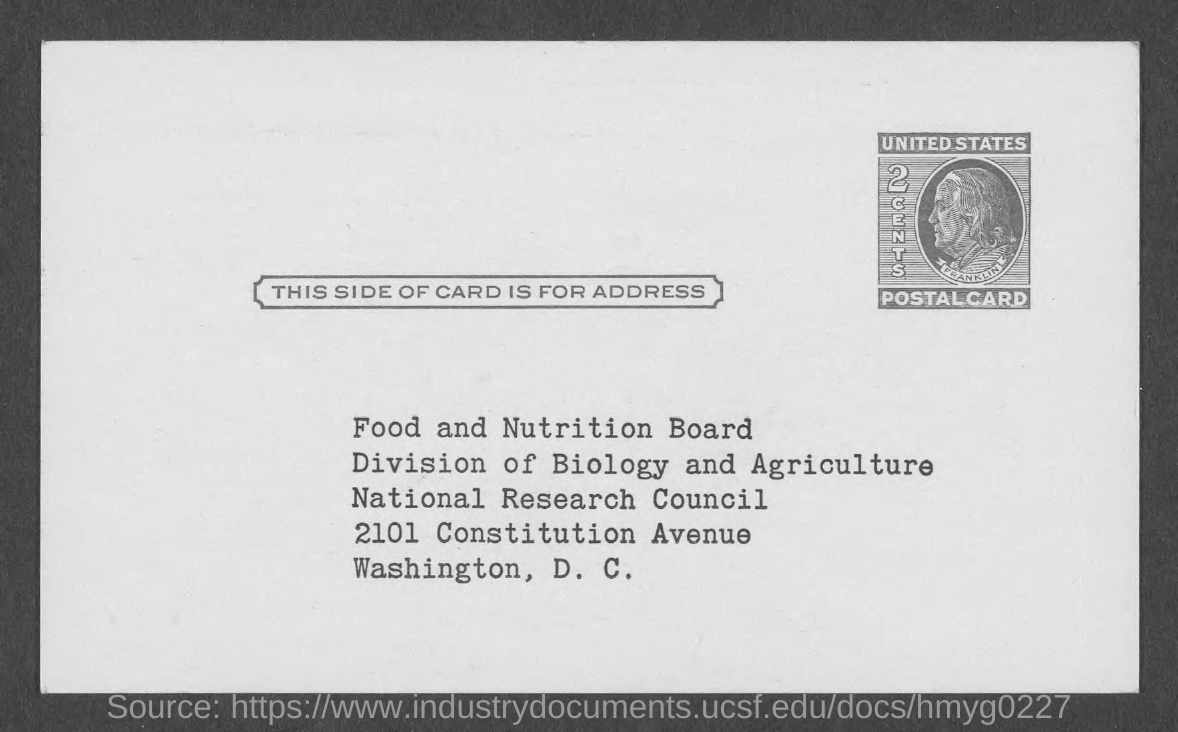Which country does the POSTAL CARD belong to?
Your answer should be very brief. UNITED STATES. What is the value of the POSTAL CARD?
Keep it short and to the point. 2 CENTS. Which place should the POSTCARD be delivered to?
Offer a very short reply. WASHINGTON, D. C. 